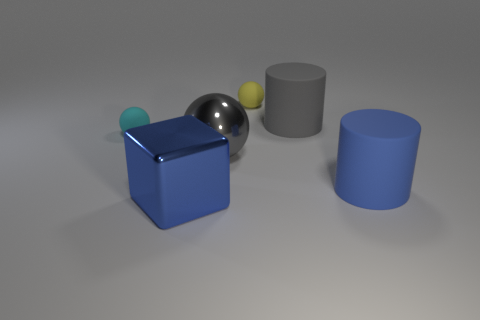Subtract all blue balls. Subtract all blue cubes. How many balls are left? 3 Add 2 cyan matte spheres. How many objects exist? 8 Subtract all blocks. How many objects are left? 5 Add 6 big brown rubber spheres. How many big brown rubber spheres exist? 6 Subtract 0 purple blocks. How many objects are left? 6 Subtract all big red things. Subtract all large metallic things. How many objects are left? 4 Add 1 gray shiny objects. How many gray shiny objects are left? 2 